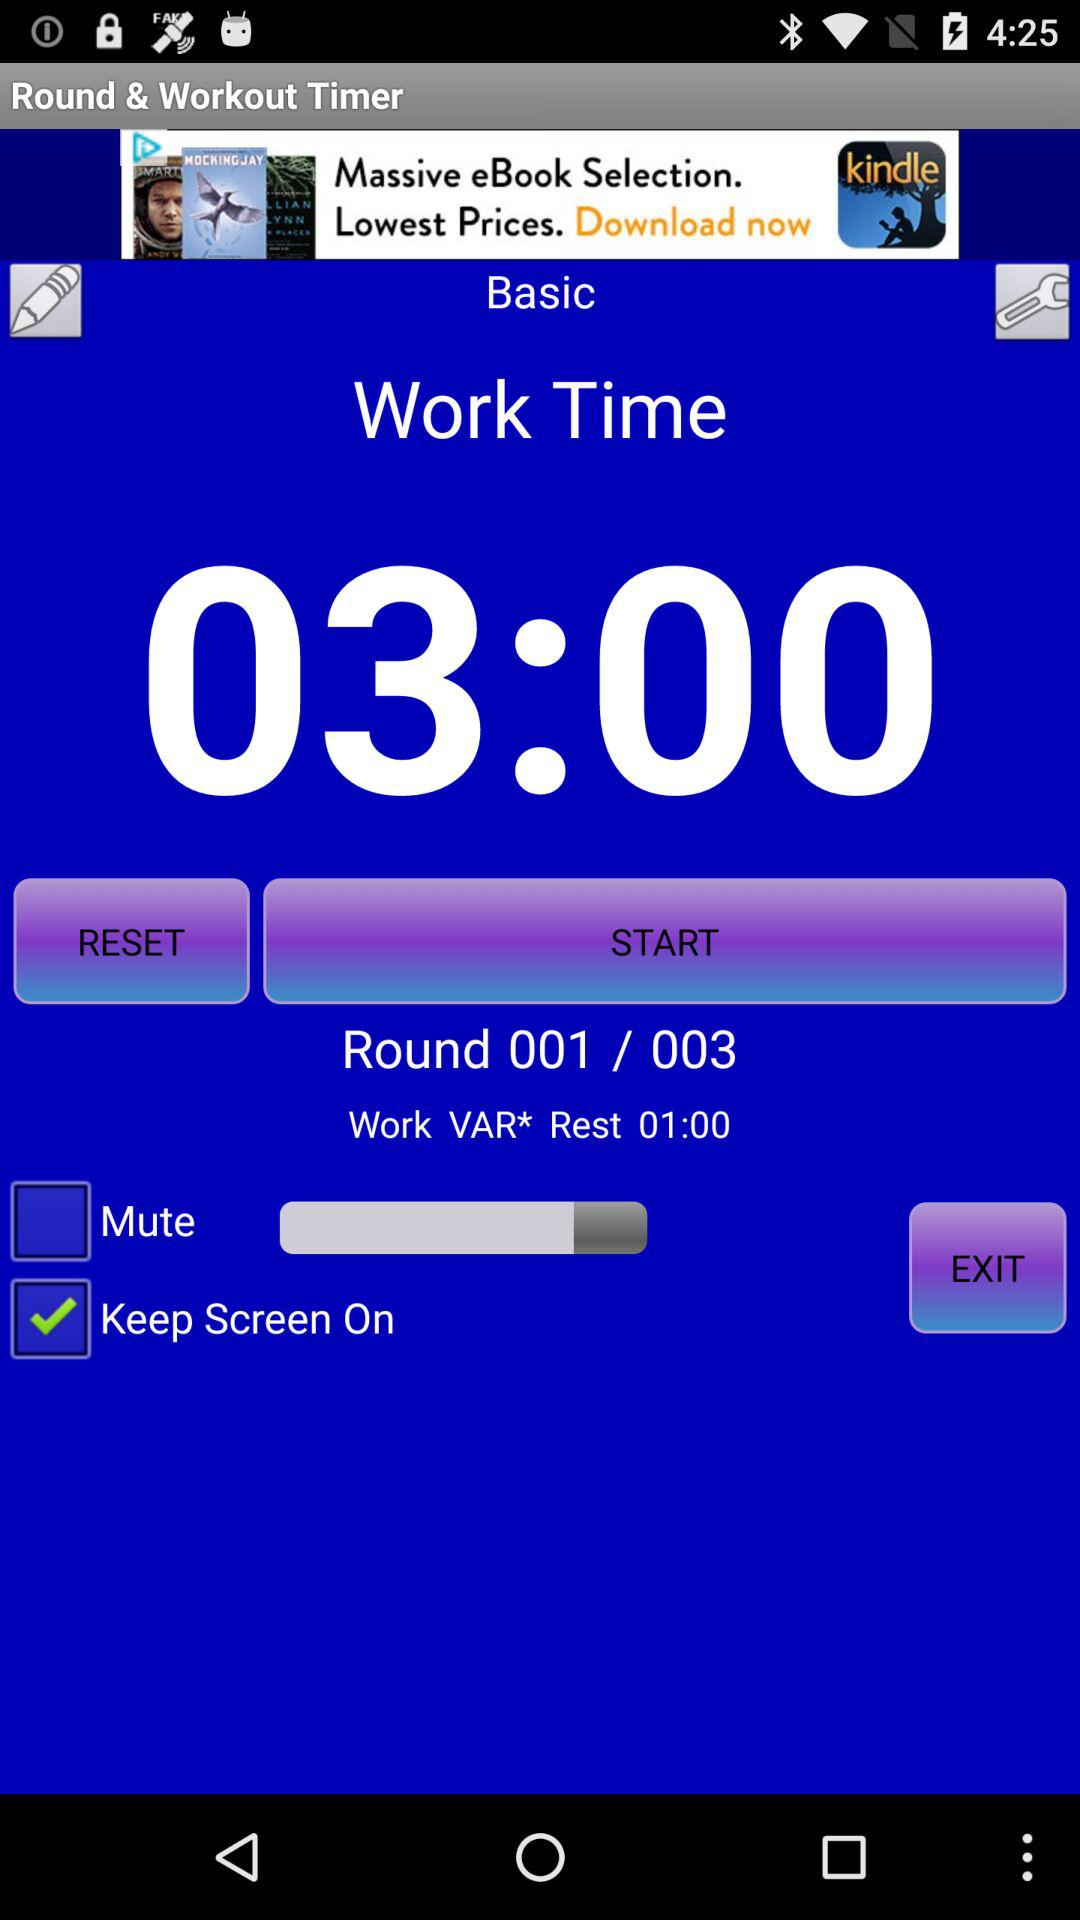Which is the current round number shown on the screen? The current round number shown on the screen is 001. 